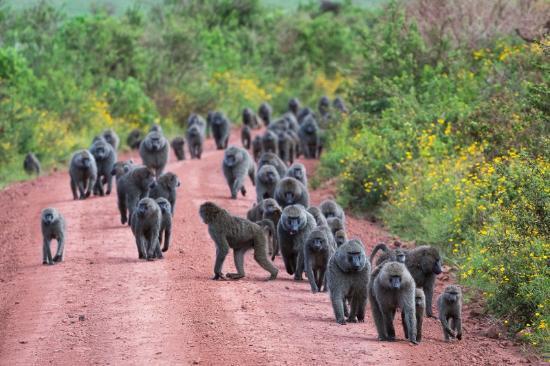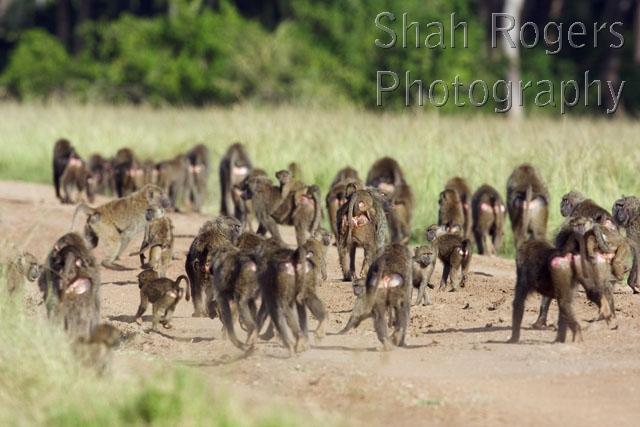The first image is the image on the left, the second image is the image on the right. For the images displayed, is the sentence "Several monkeys are sitting on top of a vehicle." factually correct? Answer yes or no. No. The first image is the image on the left, the second image is the image on the right. Analyze the images presented: Is the assertion "In one image monkeys are interacting with a white vehicle with the doors open." valid? Answer yes or no. No. 